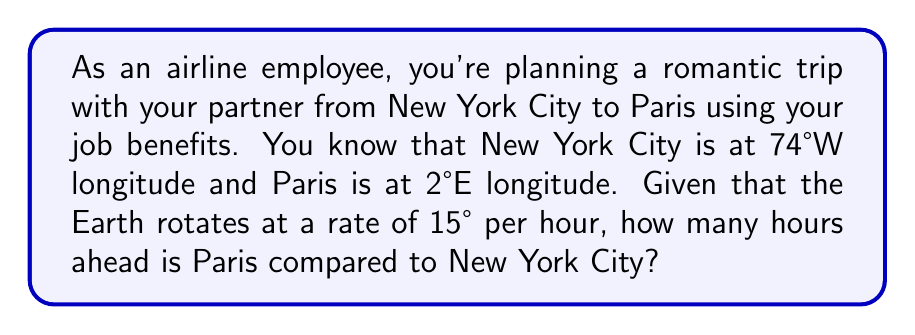Can you solve this math problem? To solve this problem, we need to follow these steps:

1. Calculate the total longitude difference between the two cities:
   $$ \text{Longitude difference} = |\text{NYC longitude} - \text{Paris longitude}| $$
   $$ = |(-74°) - (2°)| = 76° $$

2. Use the Earth's rotation rate to convert the longitude difference to time:
   $$ \text{Time difference} = \frac{\text{Longitude difference}}{\text{Earth's rotation rate}} $$

   We know that the Earth rotates 15° per hour, so we can set up the equation:
   $$ \text{Time difference} = \frac{76°}{15°/\text{hour}} $$

3. Simplify the equation:
   $$ \text{Time difference} = 76° \cdot \frac{1 \text{ hour}}{15°} = \frac{76}{15} \text{ hours} $$

4. Calculate the final result:
   $$ \text{Time difference} = 5.0666... \text{ hours} $$

5. Round to the nearest hour, as time zones are typically set in whole hours:
   $$ \text{Time difference} \approx 5 \text{ hours} $$

Therefore, Paris is approximately 5 hours ahead of New York City.
Answer: $5$ hours 